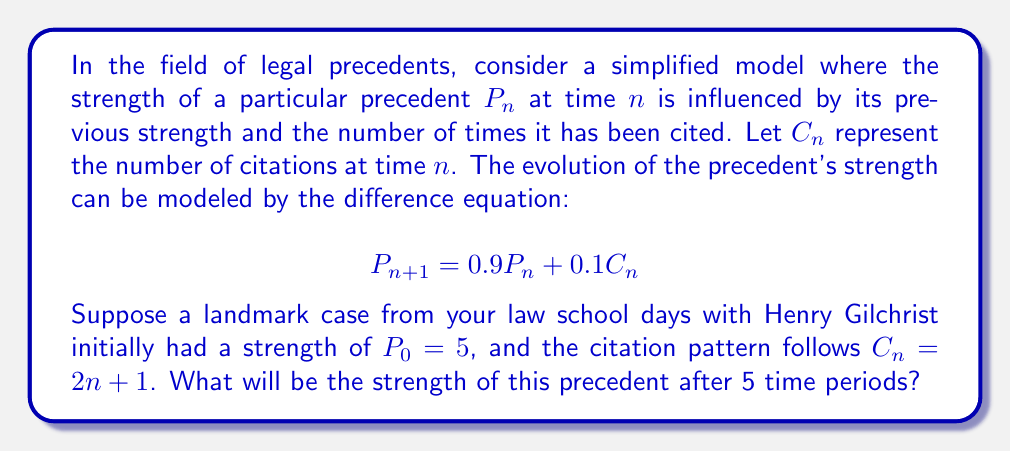Teach me how to tackle this problem. Let's approach this step-by-step:

1) We're given the difference equation: $P_{n+1} = 0.9P_n + 0.1C_n$

2) We know that $P_0 = 5$ and $C_n = 2n + 1$

3) Let's calculate $P_n$ for $n = 1$ to $5$:

   For $n = 1$:
   $P_1 = 0.9P_0 + 0.1C_0 = 0.9(5) + 0.1(2(0) + 1) = 4.5 + 0.1 = 4.6$

   For $n = 2$:
   $P_2 = 0.9P_1 + 0.1C_1 = 0.9(4.6) + 0.1(2(1) + 1) = 4.14 + 0.3 = 4.44$

   For $n = 3$:
   $P_3 = 0.9P_2 + 0.1C_2 = 0.9(4.44) + 0.1(2(2) + 1) = 3.996 + 0.5 = 4.496$

   For $n = 4$:
   $P_4 = 0.9P_3 + 0.1C_3 = 0.9(4.496) + 0.1(2(3) + 1) = 4.0464 + 0.7 = 4.7464$

   For $n = 5$:
   $P_5 = 0.9P_4 + 0.1C_4 = 0.9(4.7464) + 0.1(2(4) + 1) = 4.27176 + 0.9 = 5.17176$

4) Therefore, after 5 time periods, the strength of the precedent will be approximately 5.17.
Answer: 5.17 